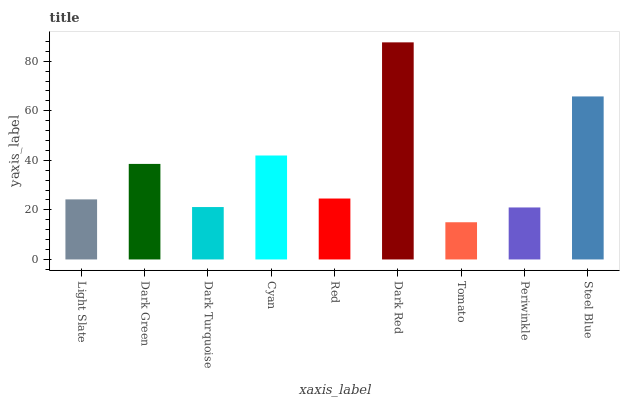Is Tomato the minimum?
Answer yes or no. Yes. Is Dark Red the maximum?
Answer yes or no. Yes. Is Dark Green the minimum?
Answer yes or no. No. Is Dark Green the maximum?
Answer yes or no. No. Is Dark Green greater than Light Slate?
Answer yes or no. Yes. Is Light Slate less than Dark Green?
Answer yes or no. Yes. Is Light Slate greater than Dark Green?
Answer yes or no. No. Is Dark Green less than Light Slate?
Answer yes or no. No. Is Red the high median?
Answer yes or no. Yes. Is Red the low median?
Answer yes or no. Yes. Is Steel Blue the high median?
Answer yes or no. No. Is Dark Turquoise the low median?
Answer yes or no. No. 